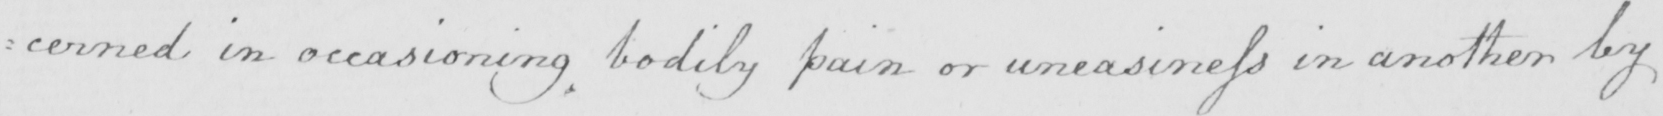Can you read and transcribe this handwriting? :cerned in occasioning bodily pain or uneasiness in another by 